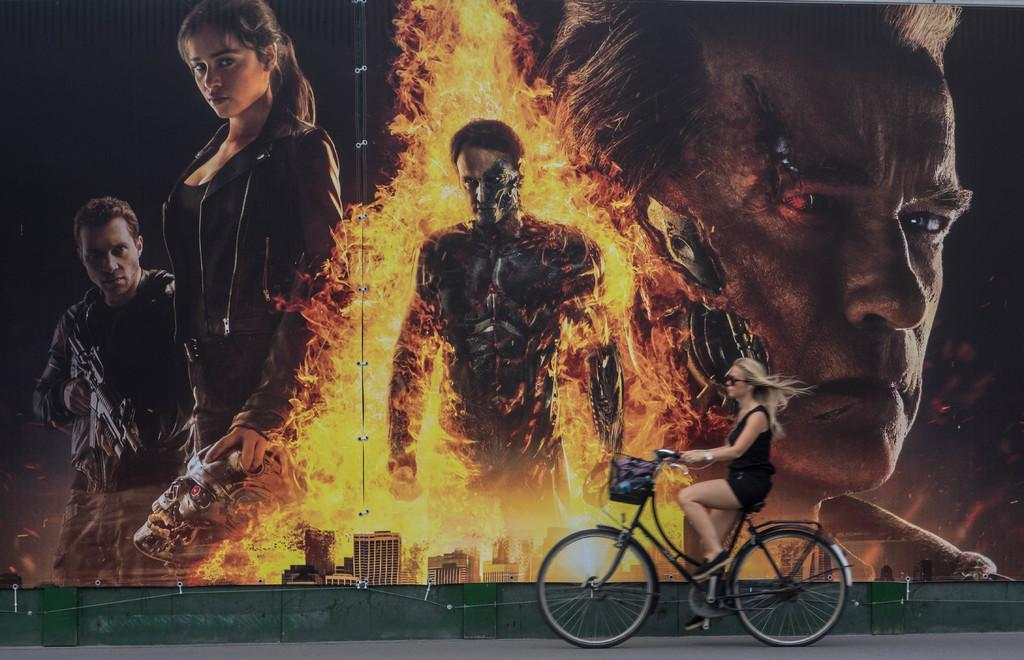How many people are present in the room? There are five people in the room. Can you describe the woman in the room? The woman is riding a bicycle. What can be seen in the background of the room? There is a screen and buildings visible in the background. What type of copper business is being conducted by the woman on the bicycle? There is no mention of copper or a business in the image, and the woman is riding a bicycle, not conducting any business. 